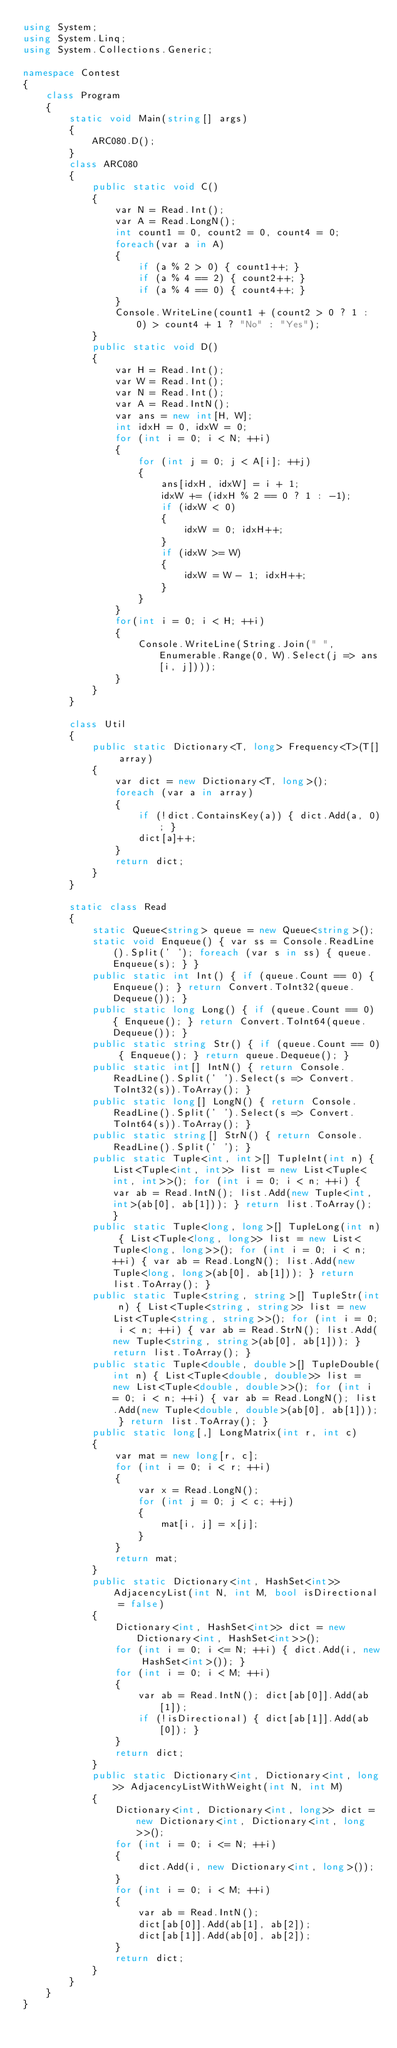<code> <loc_0><loc_0><loc_500><loc_500><_C#_>using System;
using System.Linq;
using System.Collections.Generic;

namespace Contest
{
    class Program
    {
        static void Main(string[] args)
        {
            ARC080.D();
        }
        class ARC080
        {
            public static void C()
            {
                var N = Read.Int();
                var A = Read.LongN();
                int count1 = 0, count2 = 0, count4 = 0;
                foreach(var a in A)
                {
                    if (a % 2 > 0) { count1++; }
                    if (a % 4 == 2) { count2++; }
                    if (a % 4 == 0) { count4++; }
                }
                Console.WriteLine(count1 + (count2 > 0 ? 1 : 0) > count4 + 1 ? "No" : "Yes");
            }
            public static void D()
            {
                var H = Read.Int();
                var W = Read.Int();
                var N = Read.Int();
                var A = Read.IntN();
                var ans = new int[H, W];
                int idxH = 0, idxW = 0;
                for (int i = 0; i < N; ++i)
                {
                    for (int j = 0; j < A[i]; ++j)
                    {
                        ans[idxH, idxW] = i + 1;
                        idxW += (idxH % 2 == 0 ? 1 : -1);
                        if (idxW < 0)
                        {
                            idxW = 0; idxH++;
                        }
                        if (idxW >= W)
                        {
                            idxW = W - 1; idxH++;
                        }
                    }
                }
                for(int i = 0; i < H; ++i)
                {
                    Console.WriteLine(String.Join(" ", Enumerable.Range(0, W).Select(j => ans[i, j])));
                }
            }
        }

        class Util
        {
            public static Dictionary<T, long> Frequency<T>(T[] array)
            {
                var dict = new Dictionary<T, long>();
                foreach (var a in array)
                {
                    if (!dict.ContainsKey(a)) { dict.Add(a, 0); }
                    dict[a]++;
                }
                return dict;
            }
        }

        static class Read
        {
            static Queue<string> queue = new Queue<string>();
            static void Enqueue() { var ss = Console.ReadLine().Split(' '); foreach (var s in ss) { queue.Enqueue(s); } }
            public static int Int() { if (queue.Count == 0) { Enqueue(); } return Convert.ToInt32(queue.Dequeue()); }
            public static long Long() { if (queue.Count == 0) { Enqueue(); } return Convert.ToInt64(queue.Dequeue()); }
            public static string Str() { if (queue.Count == 0) { Enqueue(); } return queue.Dequeue(); }
            public static int[] IntN() { return Console.ReadLine().Split(' ').Select(s => Convert.ToInt32(s)).ToArray(); }
            public static long[] LongN() { return Console.ReadLine().Split(' ').Select(s => Convert.ToInt64(s)).ToArray(); }
            public static string[] StrN() { return Console.ReadLine().Split(' '); }
            public static Tuple<int, int>[] TupleInt(int n) { List<Tuple<int, int>> list = new List<Tuple<int, int>>(); for (int i = 0; i < n; ++i) { var ab = Read.IntN(); list.Add(new Tuple<int, int>(ab[0], ab[1])); } return list.ToArray(); }
            public static Tuple<long, long>[] TupleLong(int n) { List<Tuple<long, long>> list = new List<Tuple<long, long>>(); for (int i = 0; i < n; ++i) { var ab = Read.LongN(); list.Add(new Tuple<long, long>(ab[0], ab[1])); } return list.ToArray(); }
            public static Tuple<string, string>[] TupleStr(int n) { List<Tuple<string, string>> list = new List<Tuple<string, string>>(); for (int i = 0; i < n; ++i) { var ab = Read.StrN(); list.Add(new Tuple<string, string>(ab[0], ab[1])); } return list.ToArray(); }
            public static Tuple<double, double>[] TupleDouble(int n) { List<Tuple<double, double>> list = new List<Tuple<double, double>>(); for (int i = 0; i < n; ++i) { var ab = Read.LongN(); list.Add(new Tuple<double, double>(ab[0], ab[1])); } return list.ToArray(); }
            public static long[,] LongMatrix(int r, int c)
            {
                var mat = new long[r, c];
                for (int i = 0; i < r; ++i)
                {
                    var x = Read.LongN();
                    for (int j = 0; j < c; ++j)
                    {
                        mat[i, j] = x[j];
                    }
                }
                return mat;
            }
            public static Dictionary<int, HashSet<int>> AdjacencyList(int N, int M, bool isDirectional = false)
            {
                Dictionary<int, HashSet<int>> dict = new Dictionary<int, HashSet<int>>();
                for (int i = 0; i <= N; ++i) { dict.Add(i, new HashSet<int>()); }
                for (int i = 0; i < M; ++i)
                {
                    var ab = Read.IntN(); dict[ab[0]].Add(ab[1]);
                    if (!isDirectional) { dict[ab[1]].Add(ab[0]); }
                }
                return dict;
            }
            public static Dictionary<int, Dictionary<int, long>> AdjacencyListWithWeight(int N, int M)
            {
                Dictionary<int, Dictionary<int, long>> dict = new Dictionary<int, Dictionary<int, long>>();
                for (int i = 0; i <= N; ++i)
                {
                    dict.Add(i, new Dictionary<int, long>());
                }
                for (int i = 0; i < M; ++i)
                {
                    var ab = Read.IntN();
                    dict[ab[0]].Add(ab[1], ab[2]);
                    dict[ab[1]].Add(ab[0], ab[2]);
                }
                return dict;
            }
        }
    }
}
</code> 